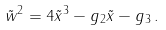<formula> <loc_0><loc_0><loc_500><loc_500>\tilde { w } ^ { 2 } = 4 \tilde { x } ^ { 3 } - g _ { 2 } \tilde { x } - g _ { 3 } \, .</formula> 